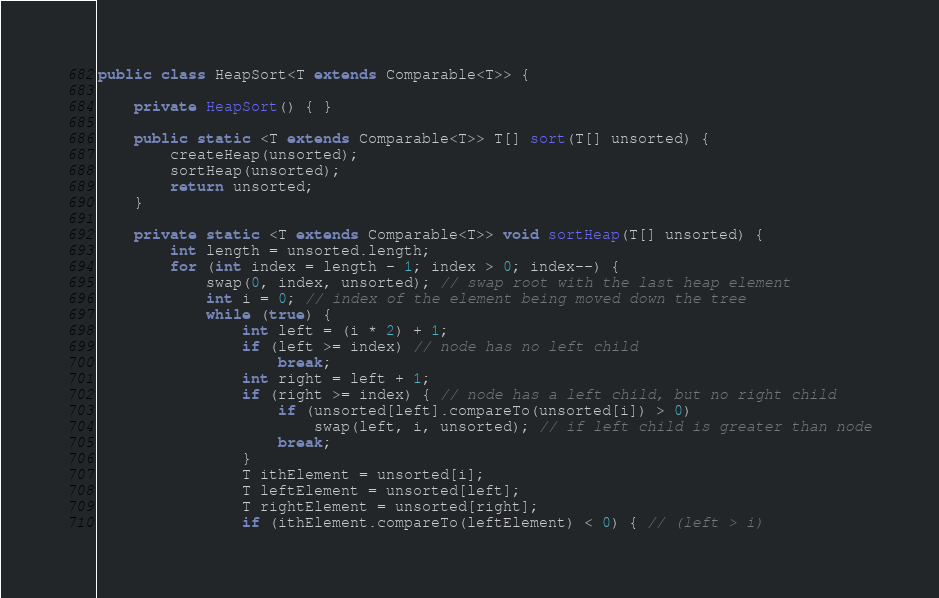<code> <loc_0><loc_0><loc_500><loc_500><_Java_>public class HeapSort<T extends Comparable<T>> {

    private HeapSort() { }

    public static <T extends Comparable<T>> T[] sort(T[] unsorted) {
        createHeap(unsorted);
        sortHeap(unsorted);
        return unsorted;
    }

    private static <T extends Comparable<T>> void sortHeap(T[] unsorted) {
        int length = unsorted.length;
        for (int index = length - 1; index > 0; index--) {
            swap(0, index, unsorted); // swap root with the last heap element
            int i = 0; // index of the element being moved down the tree
            while (true) {
                int left = (i * 2) + 1;
                if (left >= index) // node has no left child
                    break;
                int right = left + 1;
                if (right >= index) { // node has a left child, but no right child
                    if (unsorted[left].compareTo(unsorted[i]) > 0)
                        swap(left, i, unsorted); // if left child is greater than node
                    break;
                }
                T ithElement = unsorted[i];
                T leftElement = unsorted[left];
                T rightElement = unsorted[right];
                if (ithElement.compareTo(leftElement) < 0) { // (left > i)</code> 